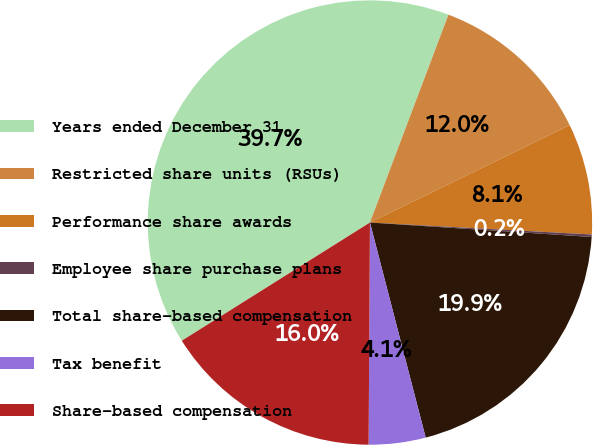<chart> <loc_0><loc_0><loc_500><loc_500><pie_chart><fcel>Years ended December 31<fcel>Restricted share units (RSUs)<fcel>Performance share awards<fcel>Employee share purchase plans<fcel>Total share-based compensation<fcel>Tax benefit<fcel>Share-based compensation<nl><fcel>39.68%<fcel>12.03%<fcel>8.08%<fcel>0.18%<fcel>19.93%<fcel>4.13%<fcel>15.98%<nl></chart> 